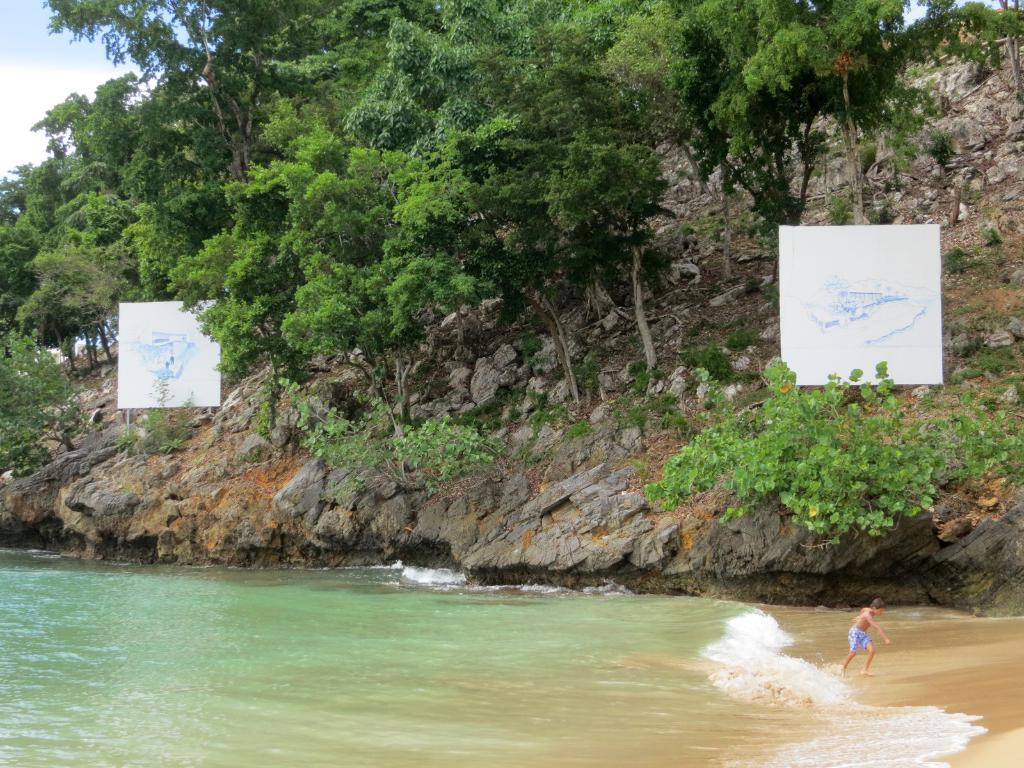What is the person in the image doing? The person is running in the image. Where is the person running? The person is running on the beach. What can be seen in the background of the image? There are trees visible in the image, and there are clouds in the sky. What is located on the mountain in the image? There are posters on a mountain in the image. What type of tools does the carpenter use to teach balance in the image? There is no carpenter or teaching activity present in the image. How does the person maintain their balance while running on the beach in the image? The image does not show the person's method of maintaining balance while running; it only shows the person running. 